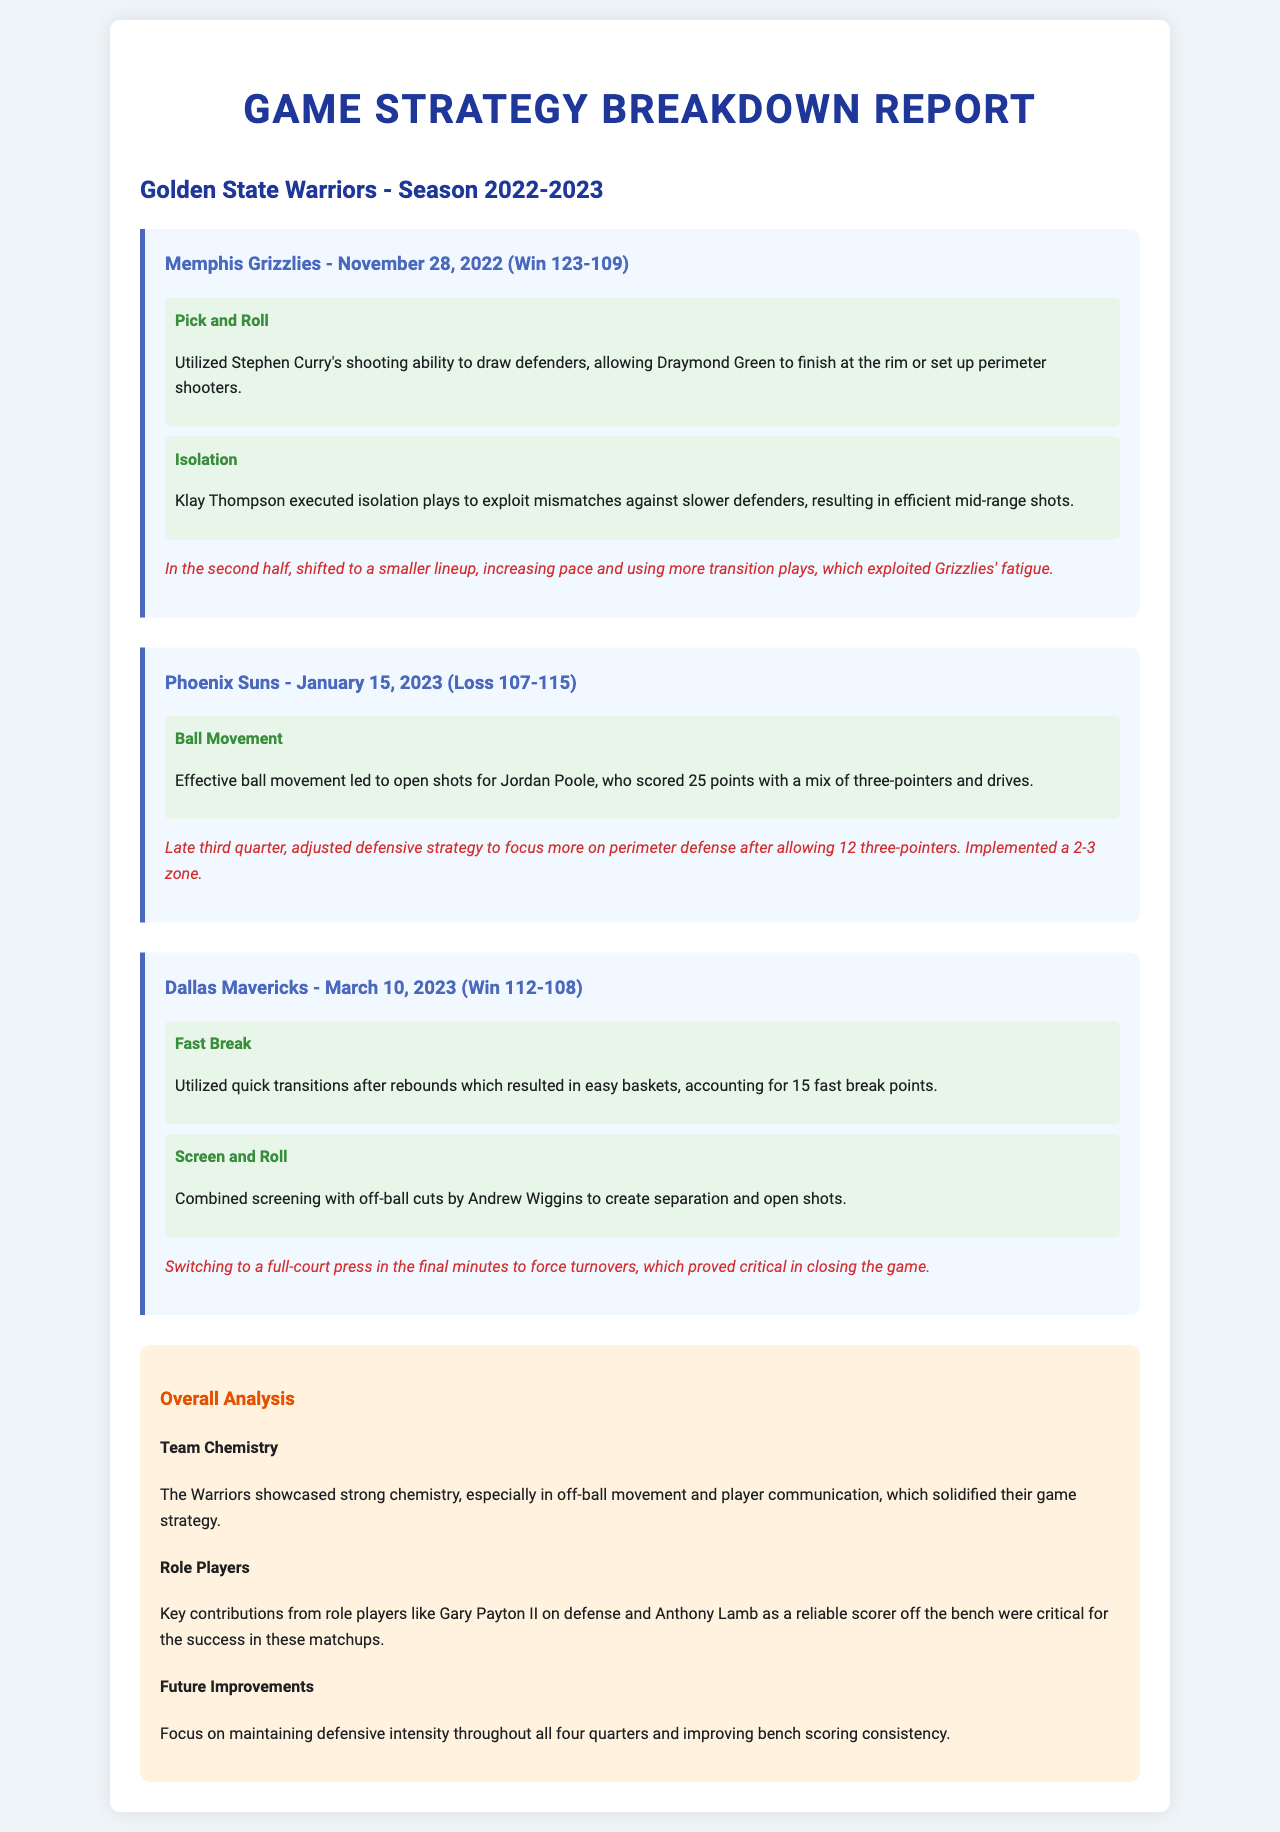what was the final score against the Memphis Grizzlies? The final score of the game against the Memphis Grizzlies on November 28, 2022, is mentioned in the document.
Answer: 123-109 who scored 25 points against the Phoenix Suns? The document specifies that Jordan Poole scored 25 points in the game against the Phoenix Suns.
Answer: Jordan Poole what type of play did Klay Thompson execute against the Memphis Grizzlies? The document provides a description of the play Klay Thompson executed during the game against the Grizzlies.
Answer: Isolation how many fast break points were scored against the Dallas Mavericks? The number of fast break points scored against the Dallas Mavericks is stated in the document.
Answer: 15 what defensive adjustment was made in the game against the Phoenix Suns? The document explains the defensive strategy adjustment made during the game against the Phoenix Suns, focusing on perimeter defense.
Answer: 2-3 zone which player contributed defensively in the overall analysis? The document mentions a specific player who contributed on defense in the overall analysis section.
Answer: Gary Payton II what was the main focus for future improvements according to the analysis? The document outlines a specific area of focus for improvement in future games within the analysis.
Answer: Defensive intensity what was utilized to close out the game against the Dallas Mavericks? The document discusses a strategy used in the final minutes to secure the win against the Mavericks.
Answer: Full-court press 